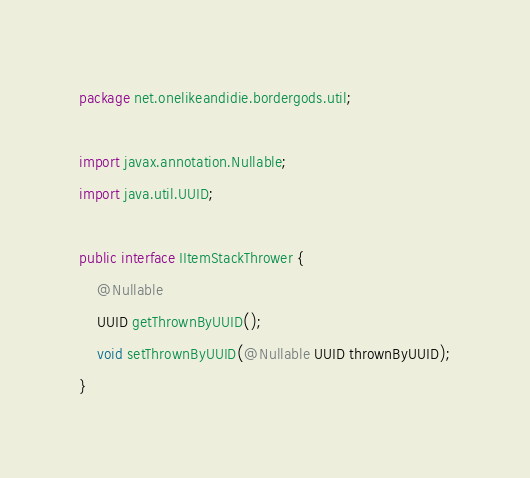Convert code to text. <code><loc_0><loc_0><loc_500><loc_500><_Java_>package net.onelikeandidie.bordergods.util;

import javax.annotation.Nullable;
import java.util.UUID;

public interface IItemStackThrower {
    @Nullable
    UUID getThrownByUUID();
    void setThrownByUUID(@Nullable UUID thrownByUUID);
}
</code> 